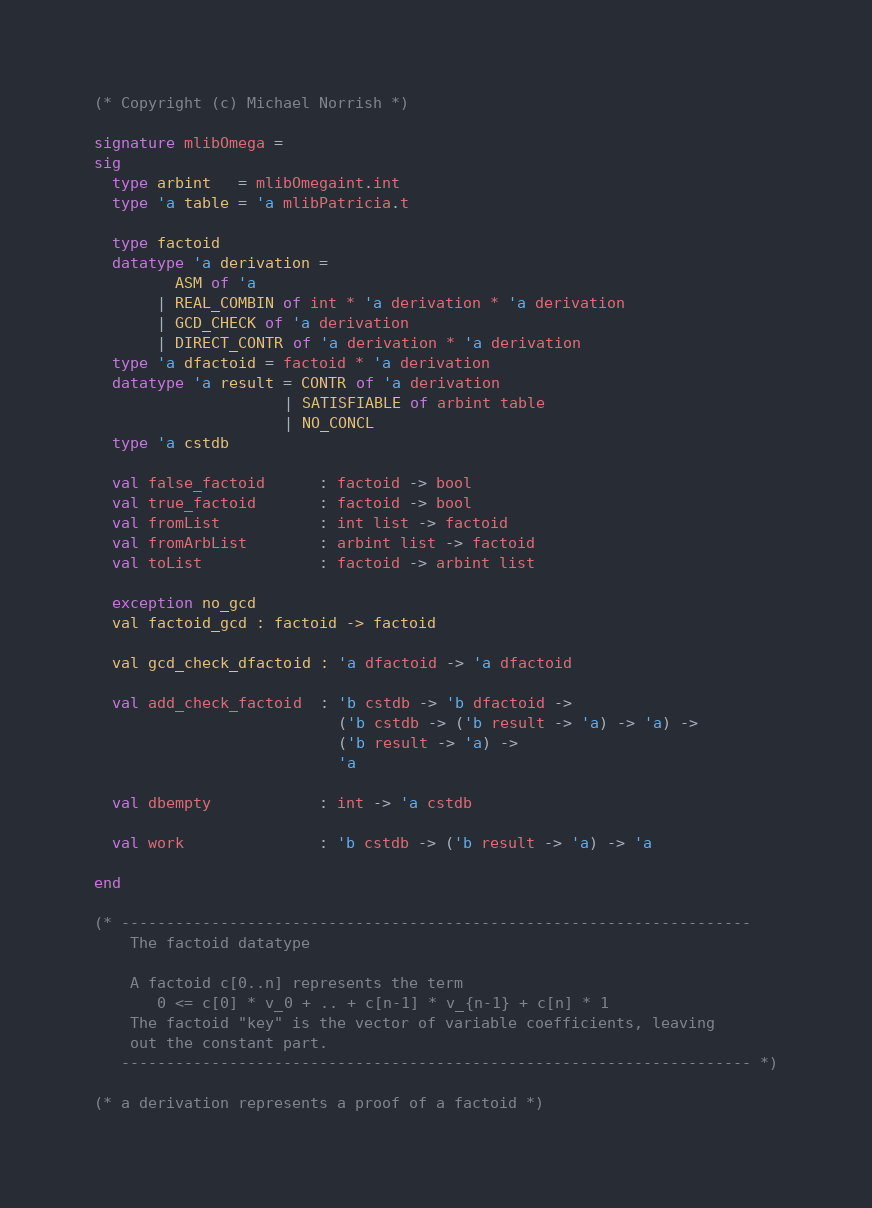Convert code to text. <code><loc_0><loc_0><loc_500><loc_500><_SML_>(* Copyright (c) Michael Norrish *)

signature mlibOmega =
sig
  type arbint   = mlibOmegaint.int
  type 'a table = 'a mlibPatricia.t

  type factoid
  datatype 'a derivation =
         ASM of 'a
       | REAL_COMBIN of int * 'a derivation * 'a derivation
       | GCD_CHECK of 'a derivation
       | DIRECT_CONTR of 'a derivation * 'a derivation
  type 'a dfactoid = factoid * 'a derivation
  datatype 'a result = CONTR of 'a derivation
                     | SATISFIABLE of arbint table
                     | NO_CONCL
  type 'a cstdb

  val false_factoid      : factoid -> bool
  val true_factoid       : factoid -> bool
  val fromList           : int list -> factoid
  val fromArbList        : arbint list -> factoid
  val toList             : factoid -> arbint list

  exception no_gcd
  val factoid_gcd : factoid -> factoid

  val gcd_check_dfactoid : 'a dfactoid -> 'a dfactoid

  val add_check_factoid  : 'b cstdb -> 'b dfactoid ->
                           ('b cstdb -> ('b result -> 'a) -> 'a) ->
                           ('b result -> 'a) ->
                           'a

  val dbempty            : int -> 'a cstdb

  val work               : 'b cstdb -> ('b result -> 'a) -> 'a

end

(* ----------------------------------------------------------------------
    The factoid datatype

    A factoid c[0..n] represents the term
       0 <= c[0] * v_0 + .. + c[n-1] * v_{n-1} + c[n] * 1
    The factoid "key" is the vector of variable coefficients, leaving
    out the constant part.
   ---------------------------------------------------------------------- *)

(* a derivation represents a proof of a factoid *)
</code> 